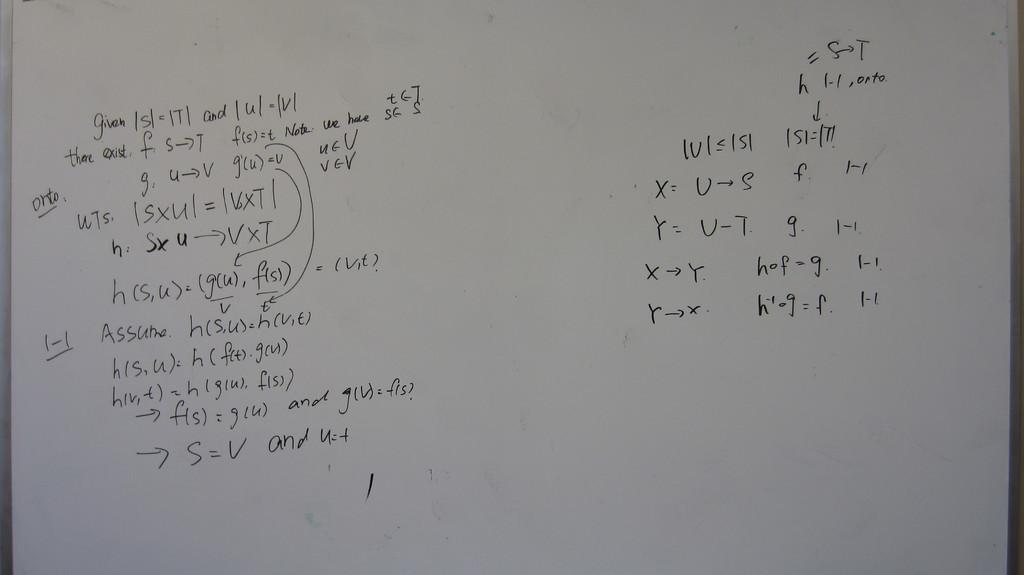<image>
Summarize the visual content of the image. A white board with a math problem on it beginning with the word given. 